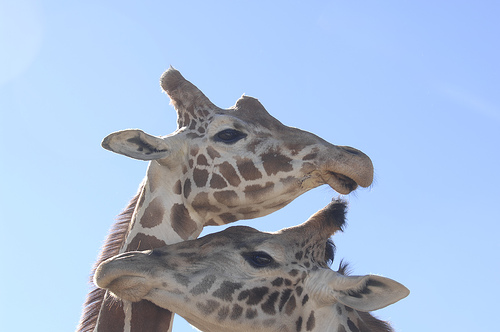<image>
Is the giraffe on the sky? No. The giraffe is not positioned on the sky. They may be near each other, but the giraffe is not supported by or resting on top of the sky. 